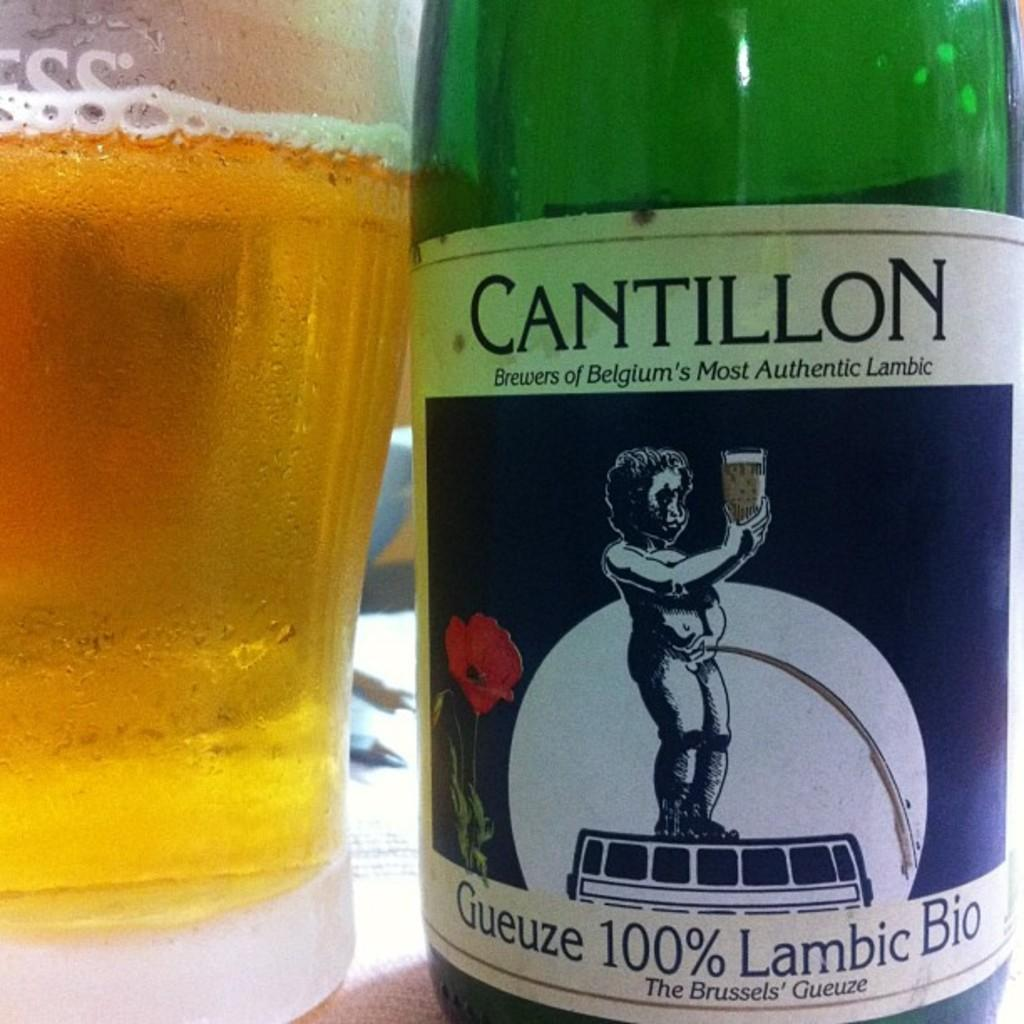What is the main object in the image with a label on it? There is a bottle with a label in the image. What is the purpose of the label on the bottle? The label on the bottle provides information about its contents. What is in the glass that is visible in the image? The glass contains beer. Where are the bottle and glass located in the image? The bottle and glass are on a table. What type of star is visible in the image? There is no star visible in the image; it features a bottle with a label, a glass containing beer, and a table. 